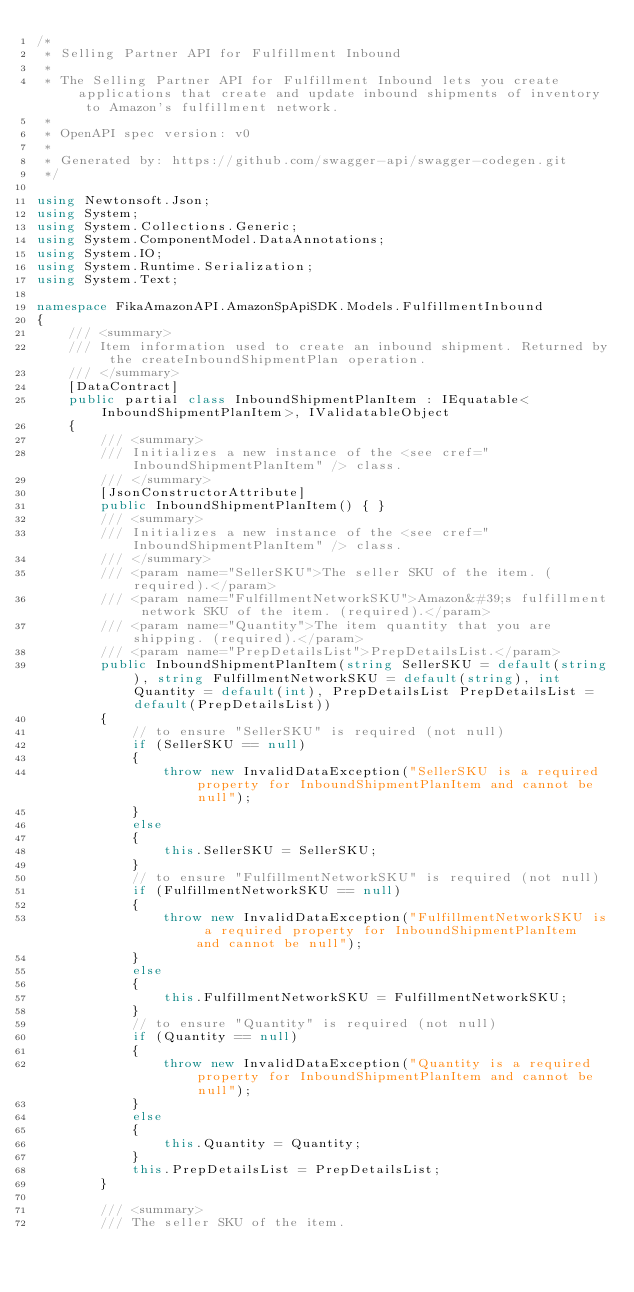Convert code to text. <code><loc_0><loc_0><loc_500><loc_500><_C#_>/* 
 * Selling Partner API for Fulfillment Inbound
 *
 * The Selling Partner API for Fulfillment Inbound lets you create applications that create and update inbound shipments of inventory to Amazon's fulfillment network.
 *
 * OpenAPI spec version: v0
 * 
 * Generated by: https://github.com/swagger-api/swagger-codegen.git
 */

using Newtonsoft.Json;
using System;
using System.Collections.Generic;
using System.ComponentModel.DataAnnotations;
using System.IO;
using System.Runtime.Serialization;
using System.Text;

namespace FikaAmazonAPI.AmazonSpApiSDK.Models.FulfillmentInbound
{
    /// <summary>
    /// Item information used to create an inbound shipment. Returned by the createInboundShipmentPlan operation.
    /// </summary>
    [DataContract]
    public partial class InboundShipmentPlanItem : IEquatable<InboundShipmentPlanItem>, IValidatableObject
    {
        /// <summary>
        /// Initializes a new instance of the <see cref="InboundShipmentPlanItem" /> class.
        /// </summary>
        [JsonConstructorAttribute]
        public InboundShipmentPlanItem() { }
        /// <summary>
        /// Initializes a new instance of the <see cref="InboundShipmentPlanItem" /> class.
        /// </summary>
        /// <param name="SellerSKU">The seller SKU of the item. (required).</param>
        /// <param name="FulfillmentNetworkSKU">Amazon&#39;s fulfillment network SKU of the item. (required).</param>
        /// <param name="Quantity">The item quantity that you are shipping. (required).</param>
        /// <param name="PrepDetailsList">PrepDetailsList.</param>
        public InboundShipmentPlanItem(string SellerSKU = default(string), string FulfillmentNetworkSKU = default(string), int Quantity = default(int), PrepDetailsList PrepDetailsList = default(PrepDetailsList))
        {
            // to ensure "SellerSKU" is required (not null)
            if (SellerSKU == null)
            {
                throw new InvalidDataException("SellerSKU is a required property for InboundShipmentPlanItem and cannot be null");
            }
            else
            {
                this.SellerSKU = SellerSKU;
            }
            // to ensure "FulfillmentNetworkSKU" is required (not null)
            if (FulfillmentNetworkSKU == null)
            {
                throw new InvalidDataException("FulfillmentNetworkSKU is a required property for InboundShipmentPlanItem and cannot be null");
            }
            else
            {
                this.FulfillmentNetworkSKU = FulfillmentNetworkSKU;
            }
            // to ensure "Quantity" is required (not null)
            if (Quantity == null)
            {
                throw new InvalidDataException("Quantity is a required property for InboundShipmentPlanItem and cannot be null");
            }
            else
            {
                this.Quantity = Quantity;
            }
            this.PrepDetailsList = PrepDetailsList;
        }

        /// <summary>
        /// The seller SKU of the item.</code> 